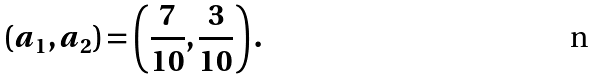<formula> <loc_0><loc_0><loc_500><loc_500>( a _ { 1 } , a _ { 2 } ) = \left ( \frac { 7 } { 1 0 } , \frac { 3 } { 1 0 } \right ) .</formula> 